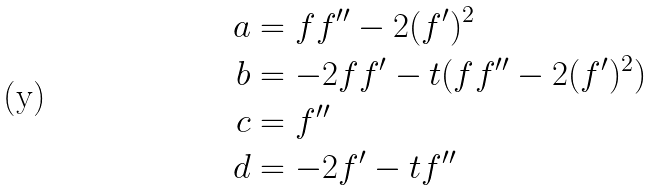<formula> <loc_0><loc_0><loc_500><loc_500>a & = f f ^ { \prime \prime } - 2 ( f ^ { \prime } ) ^ { 2 } \\ b & = - 2 f f ^ { \prime } - t ( f f ^ { \prime \prime } - 2 ( f ^ { \prime } ) ^ { 2 } ) \\ c & = f ^ { \prime \prime } \\ d & = - 2 f ^ { \prime } - t f ^ { \prime \prime }</formula> 